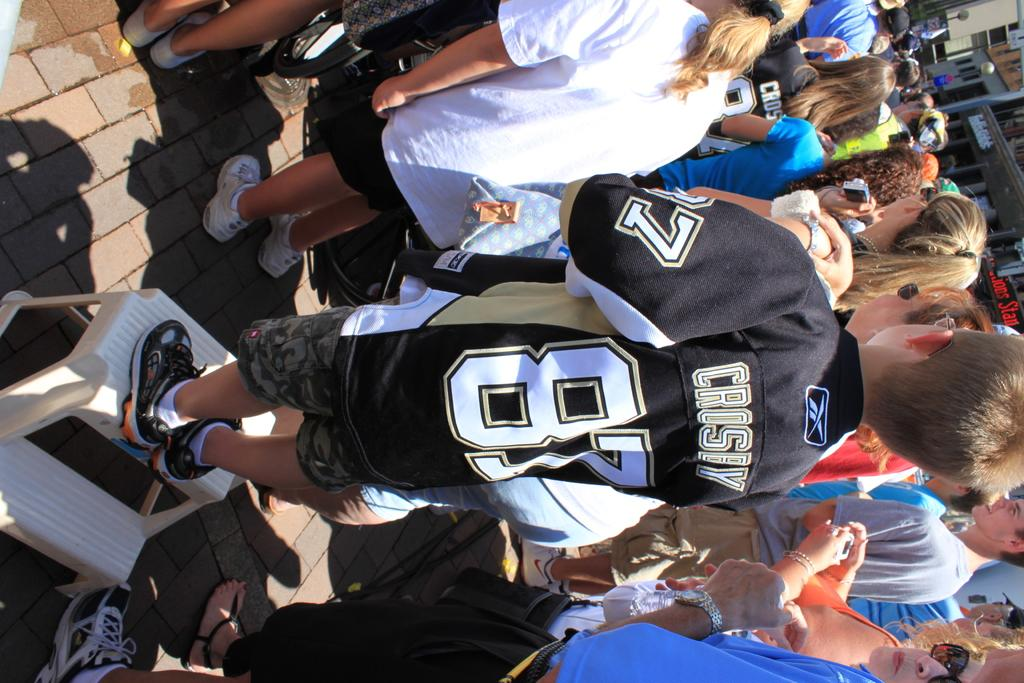<image>
Give a short and clear explanation of the subsequent image. Person wearing a jersey that says CROSBY on the back. 